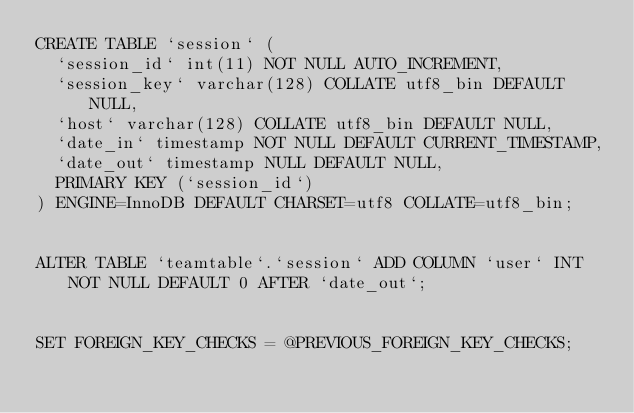<code> <loc_0><loc_0><loc_500><loc_500><_SQL_>CREATE TABLE `session` (
  `session_id` int(11) NOT NULL AUTO_INCREMENT,
  `session_key` varchar(128) COLLATE utf8_bin DEFAULT NULL,
  `host` varchar(128) COLLATE utf8_bin DEFAULT NULL,
  `date_in` timestamp NOT NULL DEFAULT CURRENT_TIMESTAMP,
  `date_out` timestamp NULL DEFAULT NULL,
  PRIMARY KEY (`session_id`)
) ENGINE=InnoDB DEFAULT CHARSET=utf8 COLLATE=utf8_bin;


ALTER TABLE `teamtable`.`session` ADD COLUMN `user` INT NOT NULL DEFAULT 0 AFTER `date_out`;


SET FOREIGN_KEY_CHECKS = @PREVIOUS_FOREIGN_KEY_CHECKS;


</code> 